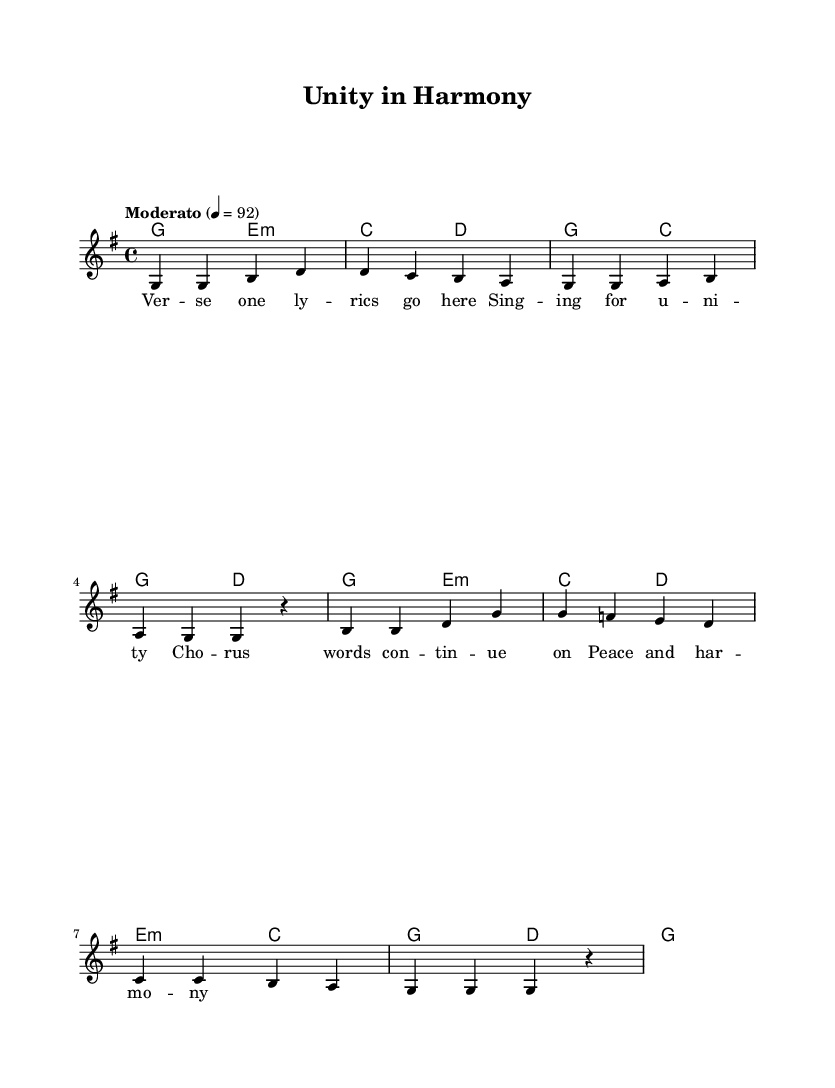What is the key signature of this music? The key signature is G major, which has one sharp (F#). This can be determined by looking at the key signature at the beginning of the staff, which indicates the specific notes that are sharp or flat in the piece.
Answer: G major What is the time signature of this music? The time signature is 4/4, as displayed at the beginning of the piece. It indicates that there are four beats in a measure and that the quarter note gets one beat.
Answer: 4/4 What is the tempo marking of this music? The tempo marking is "Moderato" with a metronome marking of 92, indicating a moderate pace at which the piece should be played. This information can be found in the tempo instruction at the start of the score.
Answer: Moderato, 92 How many measures are there in the melody? Counting the bars in the melody section reveals a total of eight measures. Each set of notes separated by vertical lines represents a measure.
Answer: 8 What is the first chord of the harmonies? The first chord in the harmonies is G major (g2). This is identifiable as it is the first entry listed under the chord names, providing the harmonic structure for the melody.
Answer: G Which lyrics correspond to the melody's repeated note after "b"? The lyrics for the repeated note after "b" are "sing-ing for u-ni-ty." By checking the alignment of lyrics below the melody, we can see they coincide with the melody's structure.
Answer: sing-ing for u-ni-ty What is the last note of the melody? The last note of the melody is a rest (r). The notation shows a rest at the end of the last measure, indicating a pause rather than a note being played.
Answer: r 